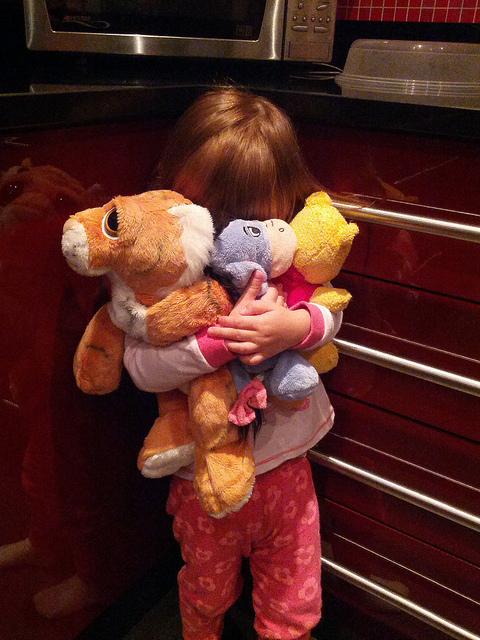Is this little girl crying?
Write a very short answer. No. Why does the blue donkey have a bow on its tail?
Give a very brief answer. Yes. What is the name of the blue donkey?
Concise answer only. Eeyore. 